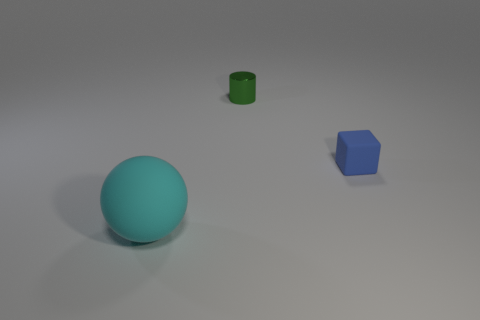Add 1 large purple metallic blocks. How many objects exist? 4 Subtract all cubes. How many objects are left? 2 Subtract all small green metallic cylinders. Subtract all blue cubes. How many objects are left? 1 Add 1 tiny cylinders. How many tiny cylinders are left? 2 Add 3 yellow matte things. How many yellow matte things exist? 3 Subtract 0 blue cylinders. How many objects are left? 3 